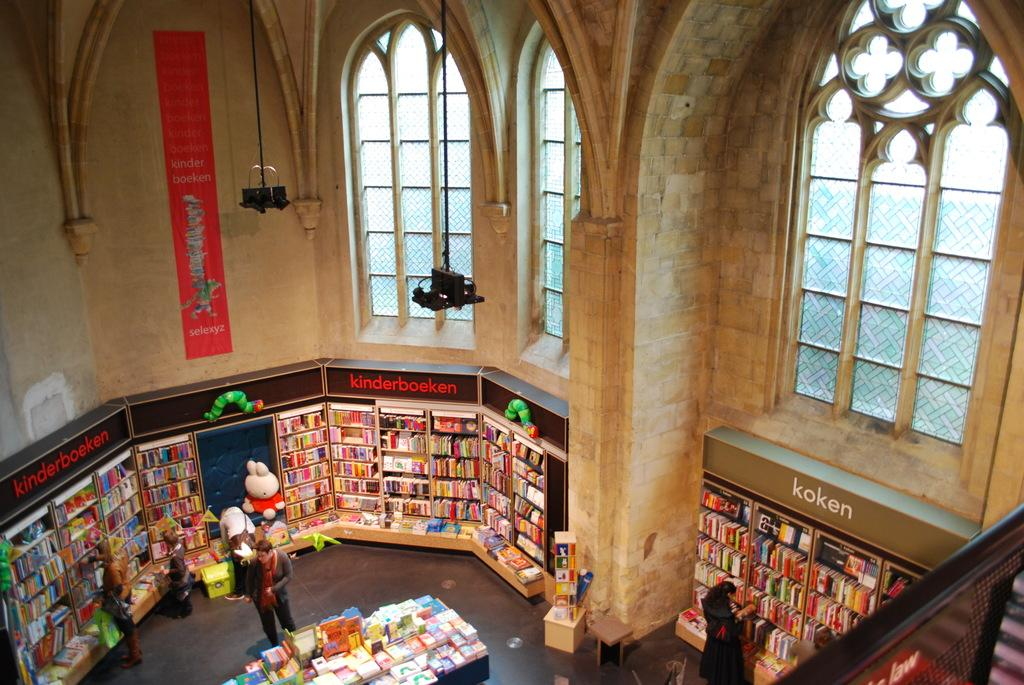<image>
Share a concise interpretation of the image provided. A foreign language book store has a section devoted to kinderboeken. 